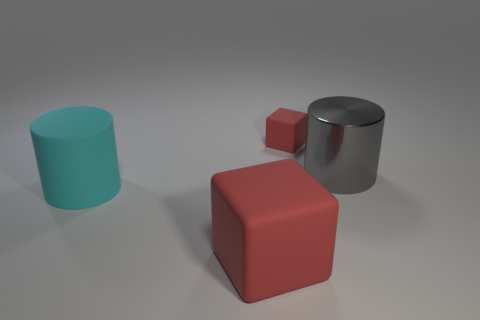There is a red cube that is right of the large red matte block; how many red objects are to the left of it?
Offer a very short reply. 1. Are there more large red blocks to the left of the gray cylinder than small gray metal blocks?
Make the answer very short. Yes. There is a thing that is in front of the gray shiny object and behind the large red object; what is its size?
Your answer should be compact. Large. What shape is the object that is in front of the small object and on the right side of the large red block?
Give a very brief answer. Cylinder. There is a red object that is behind the big matte thing to the left of the large matte cube; is there a red object that is in front of it?
Your answer should be very brief. Yes. How many things are either red things that are in front of the big gray shiny thing or cubes that are in front of the tiny cube?
Your answer should be very brief. 1. Does the big red cube that is in front of the cyan matte cylinder have the same material as the cyan cylinder?
Offer a terse response. Yes. The object that is both behind the large cyan rubber cylinder and in front of the small red matte block is made of what material?
Keep it short and to the point. Metal. What color is the cube in front of the tiny block that is right of the big cyan object?
Give a very brief answer. Red. What is the material of the other large object that is the same shape as the big metal object?
Make the answer very short. Rubber. 